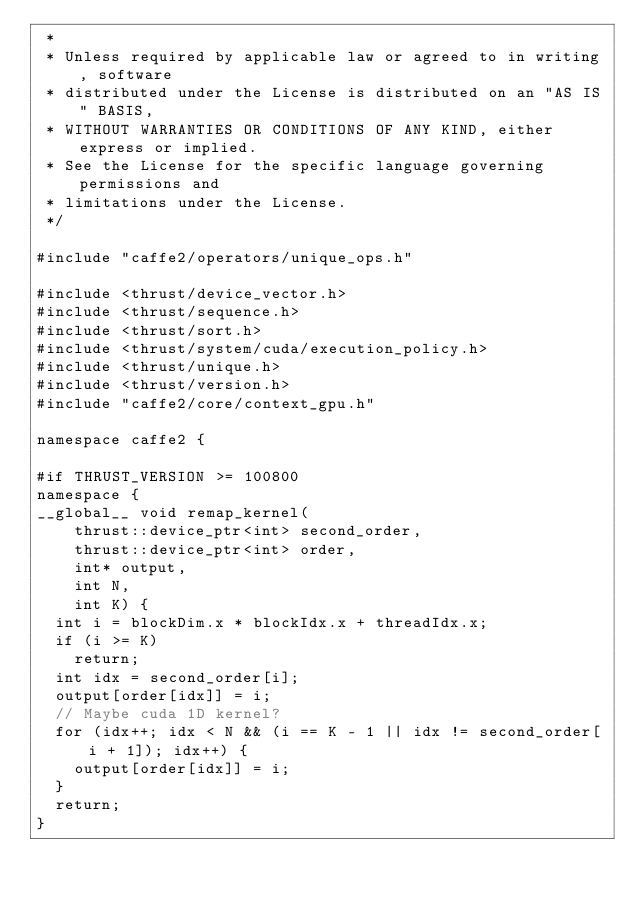Convert code to text. <code><loc_0><loc_0><loc_500><loc_500><_Cuda_> *
 * Unless required by applicable law or agreed to in writing, software
 * distributed under the License is distributed on an "AS IS" BASIS,
 * WITHOUT WARRANTIES OR CONDITIONS OF ANY KIND, either express or implied.
 * See the License for the specific language governing permissions and
 * limitations under the License.
 */

#include "caffe2/operators/unique_ops.h"

#include <thrust/device_vector.h>
#include <thrust/sequence.h>
#include <thrust/sort.h>
#include <thrust/system/cuda/execution_policy.h>
#include <thrust/unique.h>
#include <thrust/version.h>
#include "caffe2/core/context_gpu.h"

namespace caffe2 {

#if THRUST_VERSION >= 100800
namespace {
__global__ void remap_kernel(
    thrust::device_ptr<int> second_order,
    thrust::device_ptr<int> order,
    int* output,
    int N,
    int K) {
  int i = blockDim.x * blockIdx.x + threadIdx.x;
  if (i >= K)
    return;
  int idx = second_order[i];
  output[order[idx]] = i;
  // Maybe cuda 1D kernel?
  for (idx++; idx < N && (i == K - 1 || idx != second_order[i + 1]); idx++) {
    output[order[idx]] = i;
  }
  return;
}
</code> 